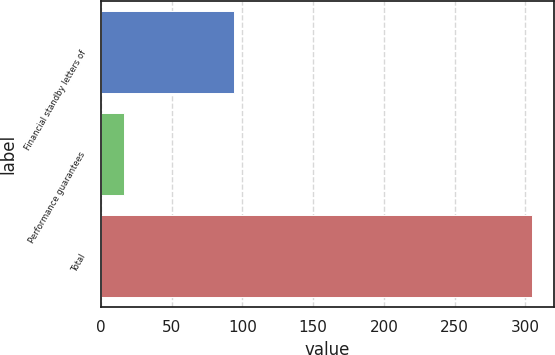<chart> <loc_0><loc_0><loc_500><loc_500><bar_chart><fcel>Financial standby letters of<fcel>Performance guarantees<fcel>Total<nl><fcel>94.2<fcel>16.3<fcel>304.9<nl></chart> 